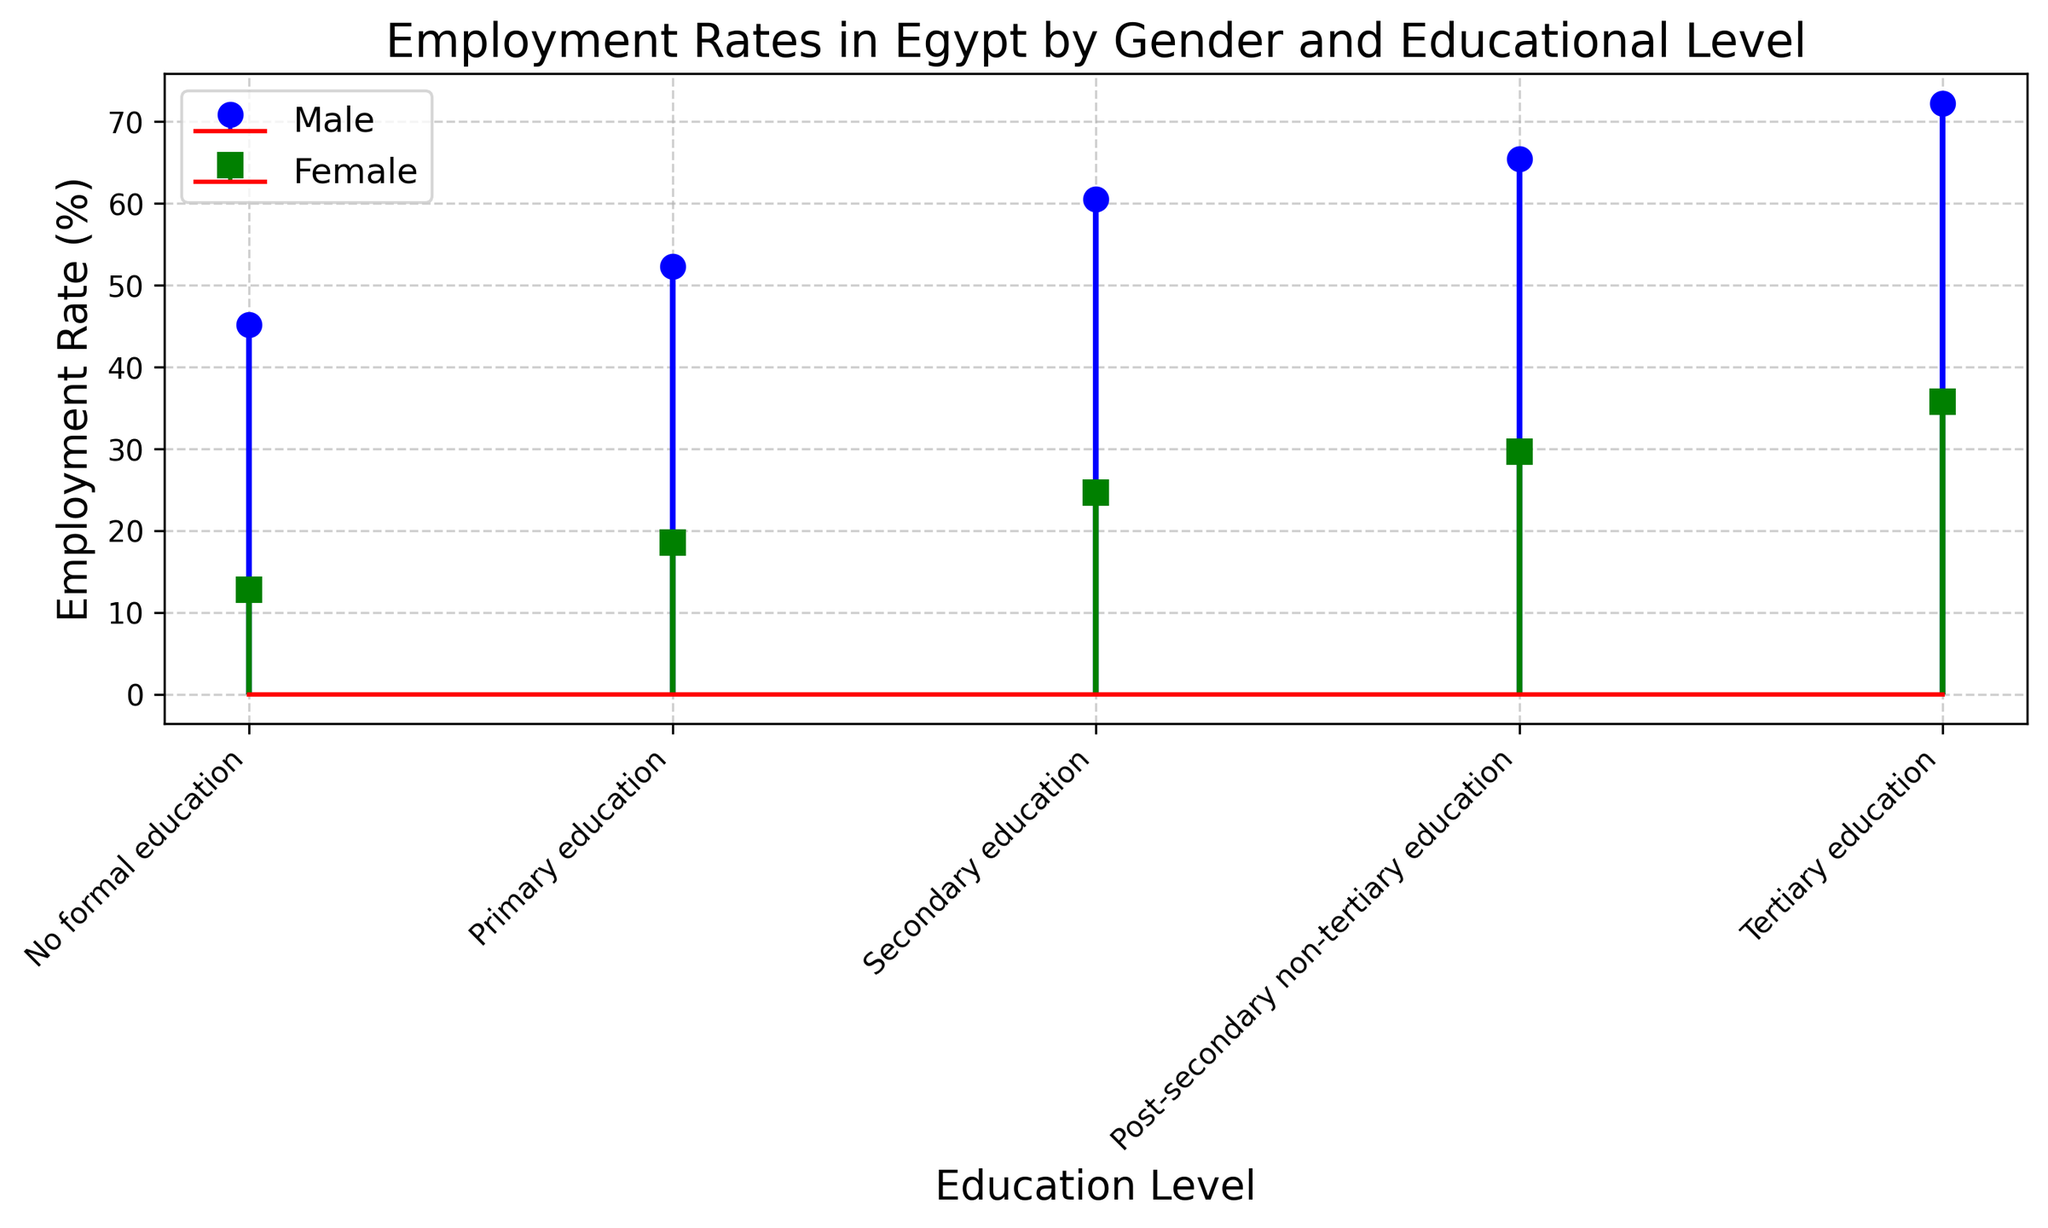What is the employment rate for males with tertiary education? Look at the stem plot for the male group's line that reaches "Tertiary education". From the plot, you can see the point marking for males at tertiary education level at 72.2%.
Answer: 72.2% Which gender has the higher employment rate at post-secondary non-tertiary education? Compare the height of the points for both males and females at the "Post-secondary non-tertiary education" level. The male point is higher than the female point.
Answer: Males What is the difference in employment rate between females with no formal education and those with secondary education? Examine the employment rates for females with "No formal education" which is 12.8%, and compare it to those with "Secondary education" which is 24.6%. Calculate the difference: 24.6% - 12.8% = 11.8%.
Answer: 11.8% How many types of education levels are represented in the plot? Count the number of unique education levels marked on the x-axis. They are: No formal education, Primary education, Secondary education, Post-secondary non-tertiary education, and Tertiary education.
Answer: 5 What trend can be observed in the employment rate of males as the education level increases? Observe the position of the points connected by the lines for the males. The trend shows the employment rate increasing progressively as the education level goes from "No formal education" up to "Tertiary education".
Answer: Increasing For females, what is the average employment rate across all educational levels? Examine the employment rates for females: 12.8%, 18.5%, 24.6%, 29.6%, and 35.7%. Sum these values: (12.8 + 18.5 + 24.6 + 29.6 + 35.7) = 121.2. Then divide by the number of education levels, which is 5. The average is 121.2 / 5 = 24.24%.
Answer: 24.24% What is the highest employment rate shown in the plot? Identify the highest point across all categories and genders. The highest rate shown in the plot is for males with "Tertiary education" at 72.2%.
Answer: 72.2% Between primary and secondary education levels, which gender shows a greater increase in employment rates? Calculate the increase for each gender between "Primary education" and "Secondary education". For males: 60.5% - 52.3% = 8.2%. For females: 24.6% - 18.5% = 6.1%. Males have a greater increase.
Answer: Males How does the employment rate for females with tertiary education compare to that of males with secondary education? Identify the points for "Females with tertiary education" (35.7%) and "Males with secondary education" (60.5%), and compare their heights. The employment rate for females with tertiary education is lower than that for males with secondary education.
Answer: Lower What is the base color of the male stem plot? Look at the color of the baseline and marker lines for males. The male group's stem plot uses blue for its markers and lines.
Answer: Blue 